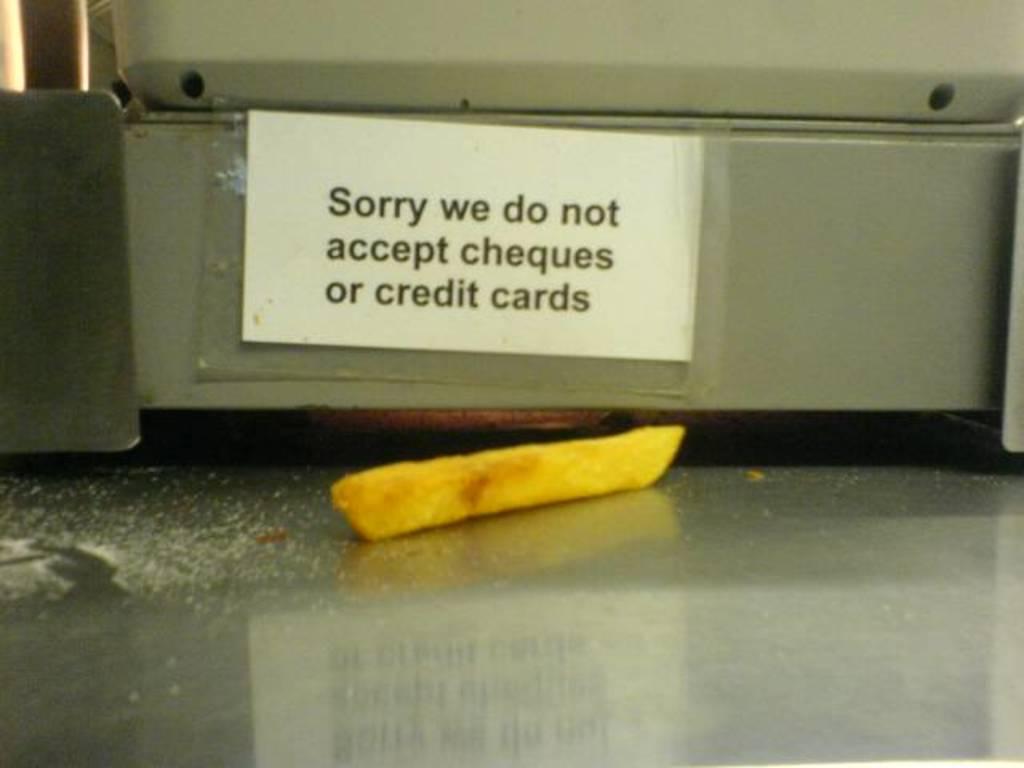Describe this image in one or two sentences. Here in this picture we can see a table, on which we can see a piece of french fry present and we can also see salt present on table and we can also see an electronic device present and on that we can see a paper pasted with some text printed on it. 